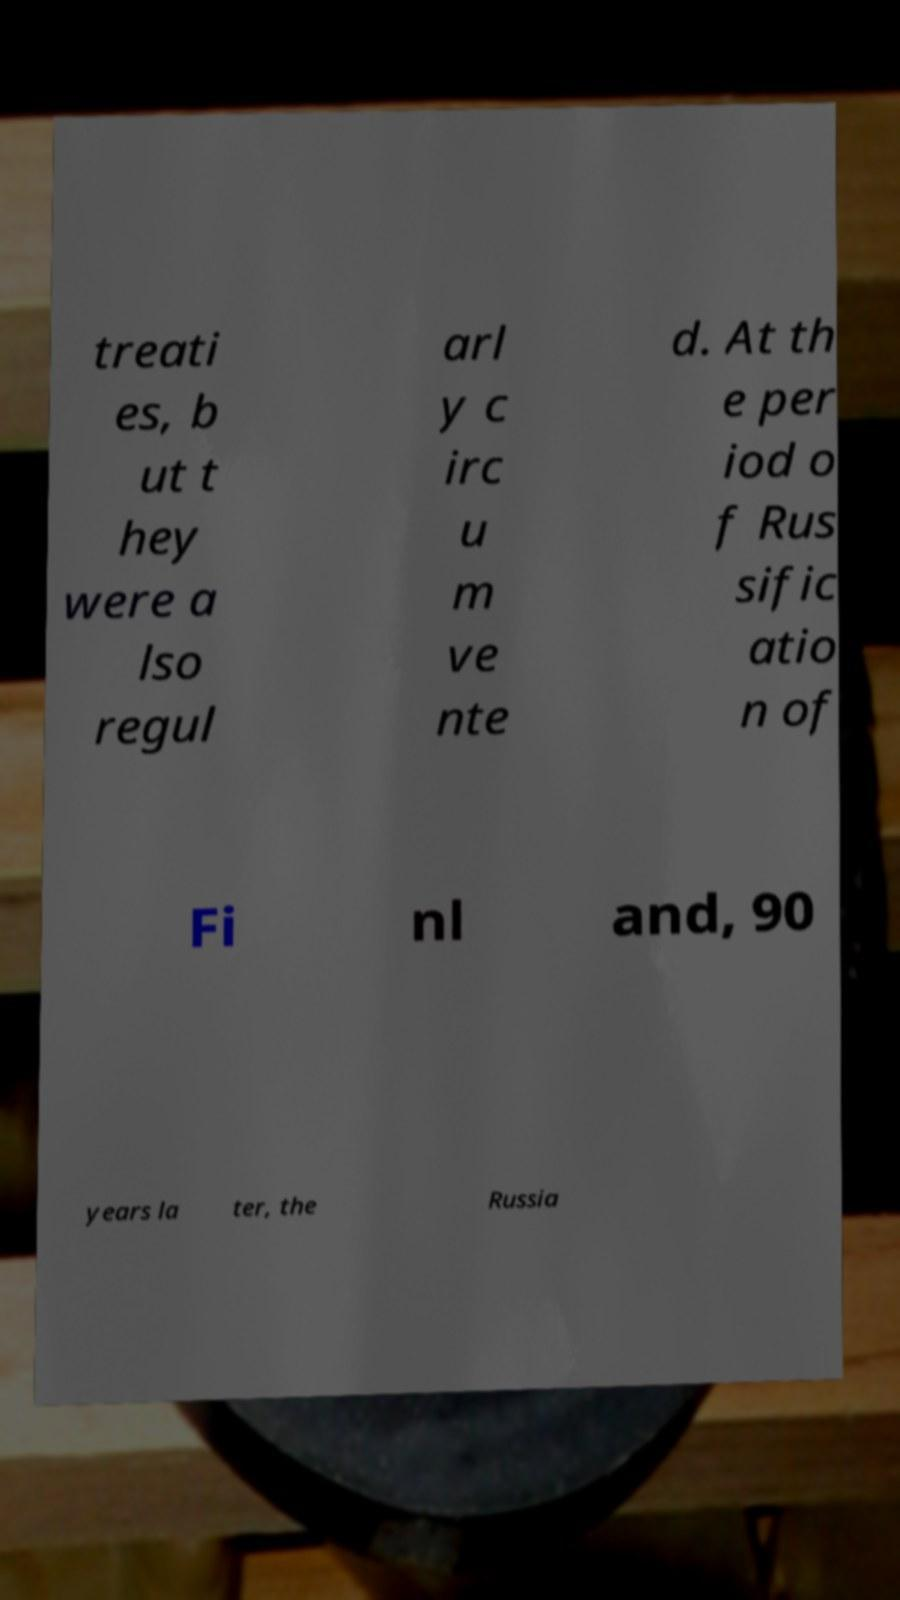I need the written content from this picture converted into text. Can you do that? treati es, b ut t hey were a lso regul arl y c irc u m ve nte d. At th e per iod o f Rus sific atio n of Fi nl and, 90 years la ter, the Russia 